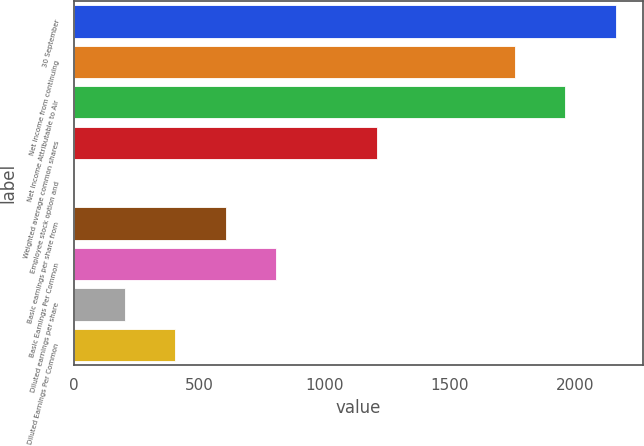<chart> <loc_0><loc_0><loc_500><loc_500><bar_chart><fcel>30 September<fcel>Net income from continuing<fcel>Net Income Attributable to Air<fcel>Weighted average common shares<fcel>Employee stock option and<fcel>Basic earnings per share from<fcel>Basic Earnings Per Common<fcel>Diluted earnings per share<fcel>Diluted Earnings Per Common<nl><fcel>2163.54<fcel>1760<fcel>1961.77<fcel>1211.92<fcel>1.3<fcel>606.61<fcel>808.38<fcel>203.07<fcel>404.84<nl></chart> 